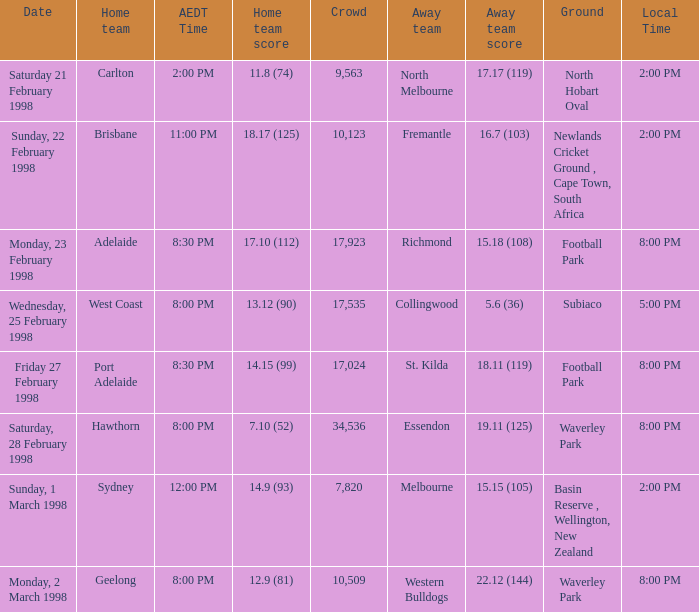Which Home team is on Wednesday, 25 february 1998? West Coast. 